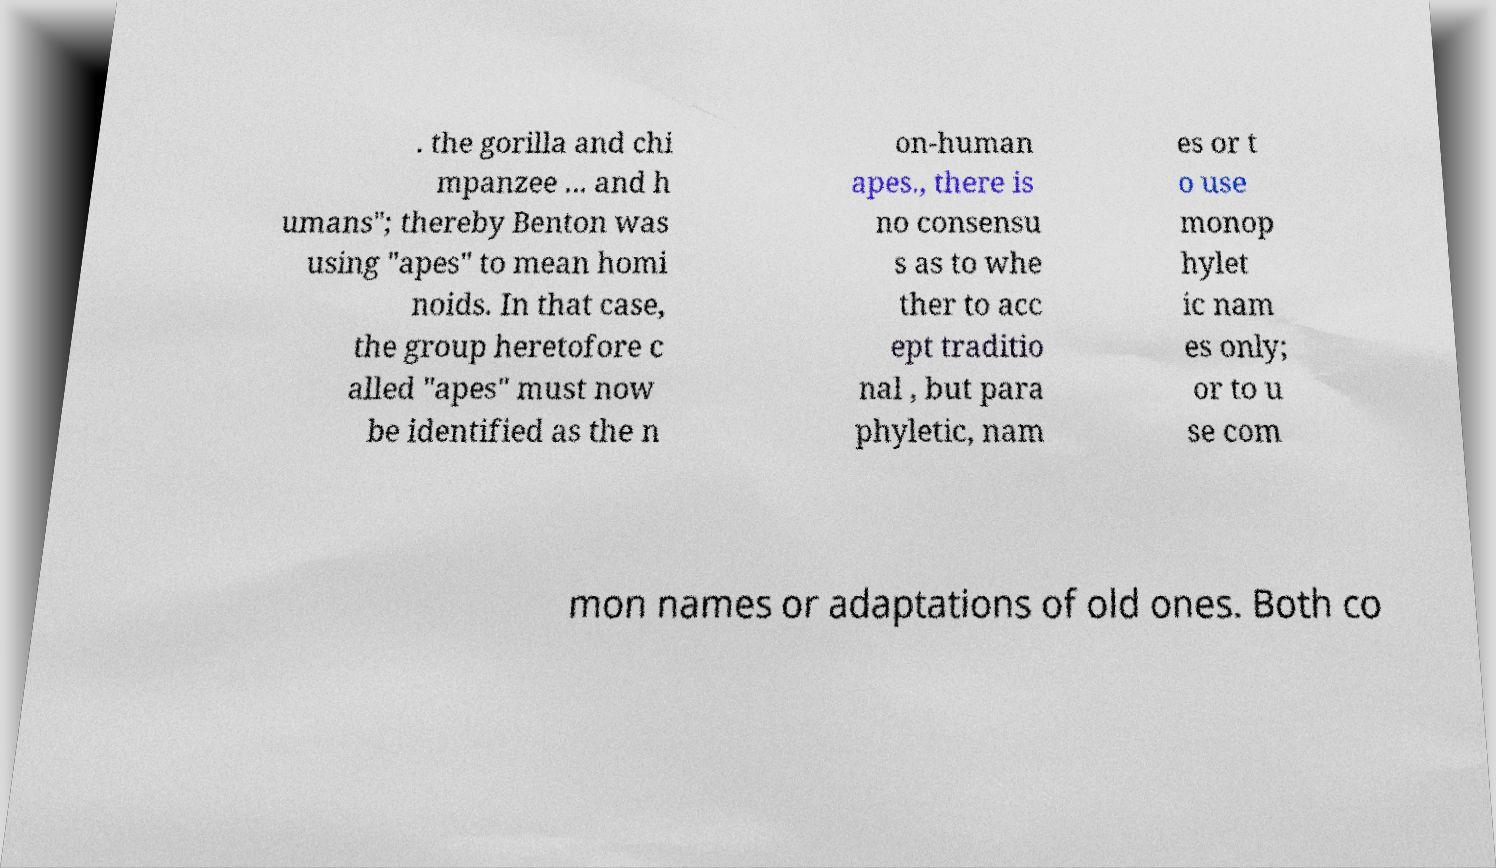Please identify and transcribe the text found in this image. . the gorilla and chi mpanzee ... and h umans"; thereby Benton was using "apes" to mean homi noids. In that case, the group heretofore c alled "apes" must now be identified as the n on-human apes., there is no consensu s as to whe ther to acc ept traditio nal , but para phyletic, nam es or t o use monop hylet ic nam es only; or to u se com mon names or adaptations of old ones. Both co 